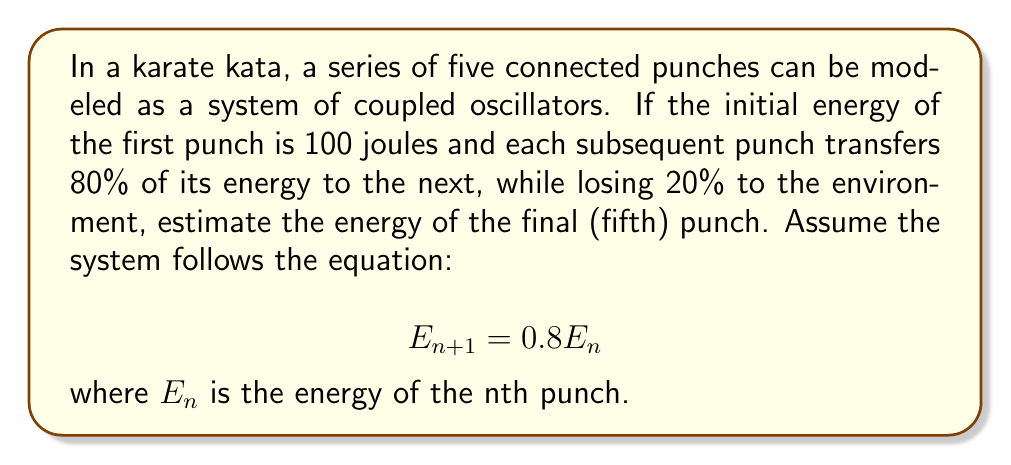Solve this math problem. To solve this problem, we'll follow these steps:

1) We start with the initial energy of the first punch: $E_1 = 100$ joules

2) For each subsequent punch, we multiply the energy by 0.8:

   $E_2 = 0.8E_1 = 0.8 * 100 = 80$ joules
   
   $E_3 = 0.8E_2 = 0.8 * 80 = 64$ joules
   
   $E_4 = 0.8E_3 = 0.8 * 64 = 51.2$ joules
   
   $E_5 = 0.8E_4 = 0.8 * 51.2 = 40.96$ joules

3) We can also express this as a single equation:

   $$E_5 = 100 * (0.8)^4 = 40.96$$ joules

This models the energy transfer in the kata as a series of coupled oscillators, where each oscillator (punch) transfers a fraction of its energy to the next one in the sequence.
Answer: 40.96 joules 